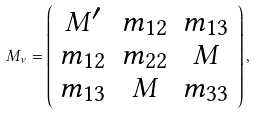Convert formula to latex. <formula><loc_0><loc_0><loc_500><loc_500>M _ { \nu } = \left ( \begin{array} { c c c } M ^ { \prime } & m _ { 1 2 } & m _ { 1 3 } \\ m _ { 1 2 } & m _ { 2 2 } & M \\ m _ { 1 3 } & M & m _ { 3 3 } \end{array} \right ) ,</formula> 